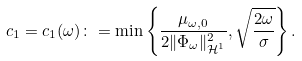<formula> <loc_0><loc_0><loc_500><loc_500>c _ { 1 } = c _ { 1 } ( \omega ) \colon = \min \left \{ \frac { \mu _ { \omega , 0 } } { 2 \| \Phi _ { \omega } \| _ { \mathcal { H } ^ { 1 } } ^ { 2 } } , \sqrt { \frac { 2 \omega } { \sigma } } \right \} .</formula> 